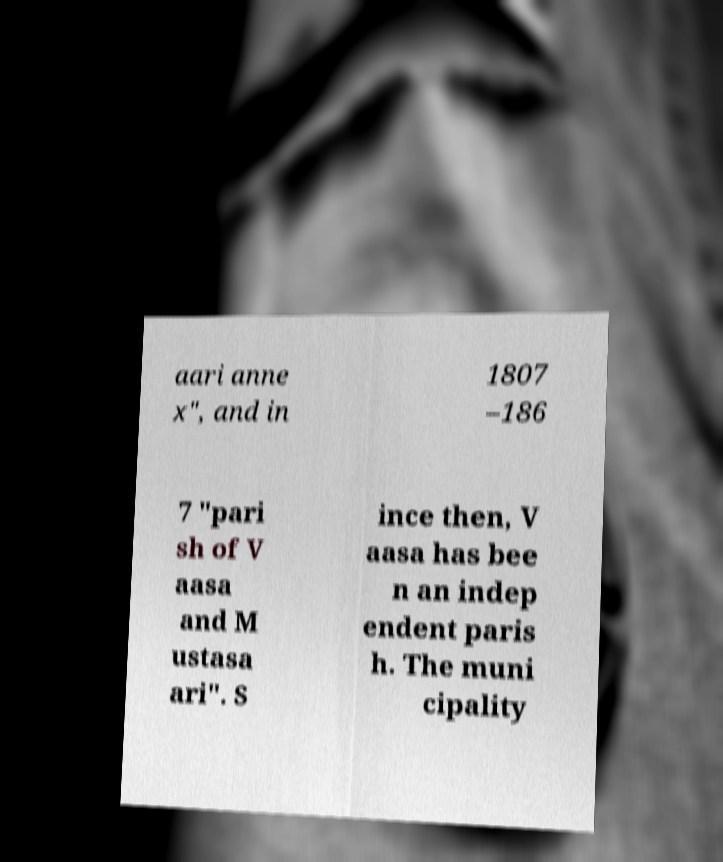Could you extract and type out the text from this image? aari anne x", and in 1807 –186 7 "pari sh of V aasa and M ustasa ari". S ince then, V aasa has bee n an indep endent paris h. The muni cipality 